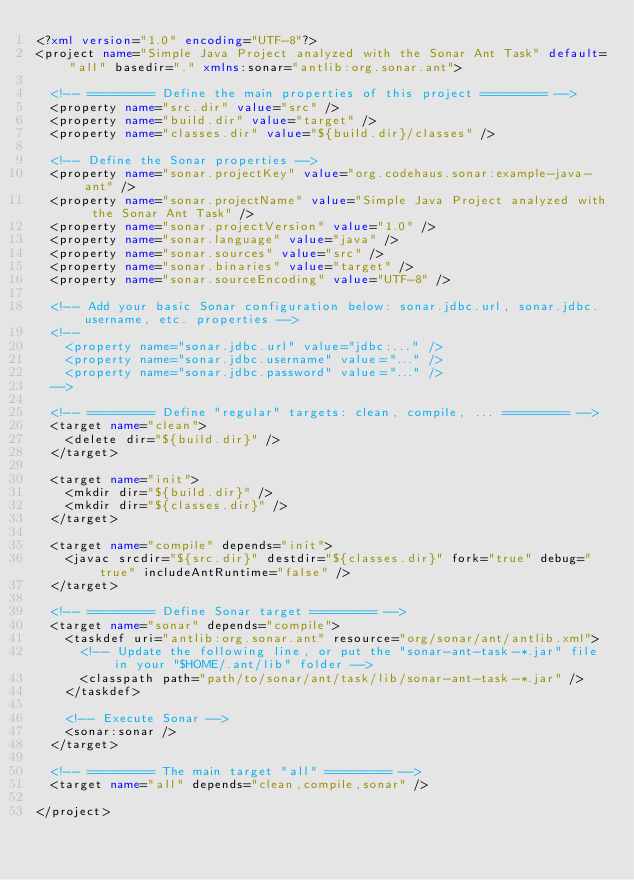<code> <loc_0><loc_0><loc_500><loc_500><_XML_><?xml version="1.0" encoding="UTF-8"?>
<project name="Simple Java Project analyzed with the Sonar Ant Task" default="all" basedir="." xmlns:sonar="antlib:org.sonar.ant">

	<!-- ========= Define the main properties of this project ========= -->
	<property name="src.dir" value="src" />
	<property name="build.dir" value="target" />
	<property name="classes.dir" value="${build.dir}/classes" />
	
	<!-- Define the Sonar properties -->
	<property name="sonar.projectKey" value="org.codehaus.sonar:example-java-ant" />
	<property name="sonar.projectName" value="Simple Java Project analyzed with the Sonar Ant Task" />
	<property name="sonar.projectVersion" value="1.0" />
	<property name="sonar.language" value="java" />
	<property name="sonar.sources" value="src" />
	<property name="sonar.binaries" value="target" />
	<property name="sonar.sourceEncoding" value="UTF-8" />
	
	<!-- Add your basic Sonar configuration below: sonar.jdbc.url, sonar.jdbc.username, etc. properties -->
	<!--
	  <property name="sonar.jdbc.url" value="jdbc:..." />
	  <property name="sonar.jdbc.username" value="..." />
	  <property name="sonar.jdbc.password" value="..." />
	-->

	<!-- ========= Define "regular" targets: clean, compile, ... ========= -->
	<target name="clean">
		<delete dir="${build.dir}" />
	</target>

	<target name="init">
		<mkdir dir="${build.dir}" />
		<mkdir dir="${classes.dir}" />
	</target>

	<target name="compile" depends="init">
		<javac srcdir="${src.dir}" destdir="${classes.dir}" fork="true" debug="true" includeAntRuntime="false" />
	</target>

	<!-- ========= Define Sonar target ========= -->
	<target name="sonar" depends="compile">
		<taskdef uri="antlib:org.sonar.ant" resource="org/sonar/ant/antlib.xml">
			<!-- Update the following line, or put the "sonar-ant-task-*.jar" file in your "$HOME/.ant/lib" folder -->
			<classpath path="path/to/sonar/ant/task/lib/sonar-ant-task-*.jar" />
		</taskdef>
		
		<!-- Execute Sonar -->
		<sonar:sonar />
	</target>

	<!-- ========= The main target "all" ========= -->
	<target name="all" depends="clean,compile,sonar" />

</project>
</code> 